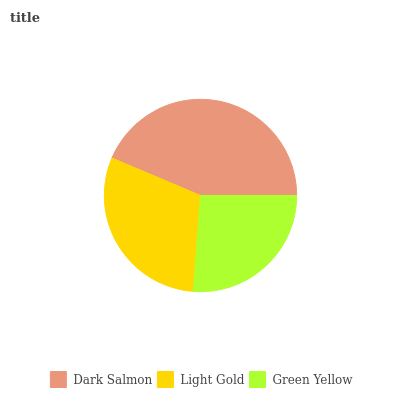Is Green Yellow the minimum?
Answer yes or no. Yes. Is Dark Salmon the maximum?
Answer yes or no. Yes. Is Light Gold the minimum?
Answer yes or no. No. Is Light Gold the maximum?
Answer yes or no. No. Is Dark Salmon greater than Light Gold?
Answer yes or no. Yes. Is Light Gold less than Dark Salmon?
Answer yes or no. Yes. Is Light Gold greater than Dark Salmon?
Answer yes or no. No. Is Dark Salmon less than Light Gold?
Answer yes or no. No. Is Light Gold the high median?
Answer yes or no. Yes. Is Light Gold the low median?
Answer yes or no. Yes. Is Dark Salmon the high median?
Answer yes or no. No. Is Green Yellow the low median?
Answer yes or no. No. 